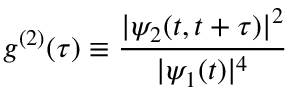Convert formula to latex. <formula><loc_0><loc_0><loc_500><loc_500>g ^ { ( 2 ) } ( \tau ) \equiv \frac { | \psi _ { 2 } ( t , t + \tau ) | ^ { 2 } } { | \psi _ { 1 } ( t ) | ^ { 4 } }</formula> 